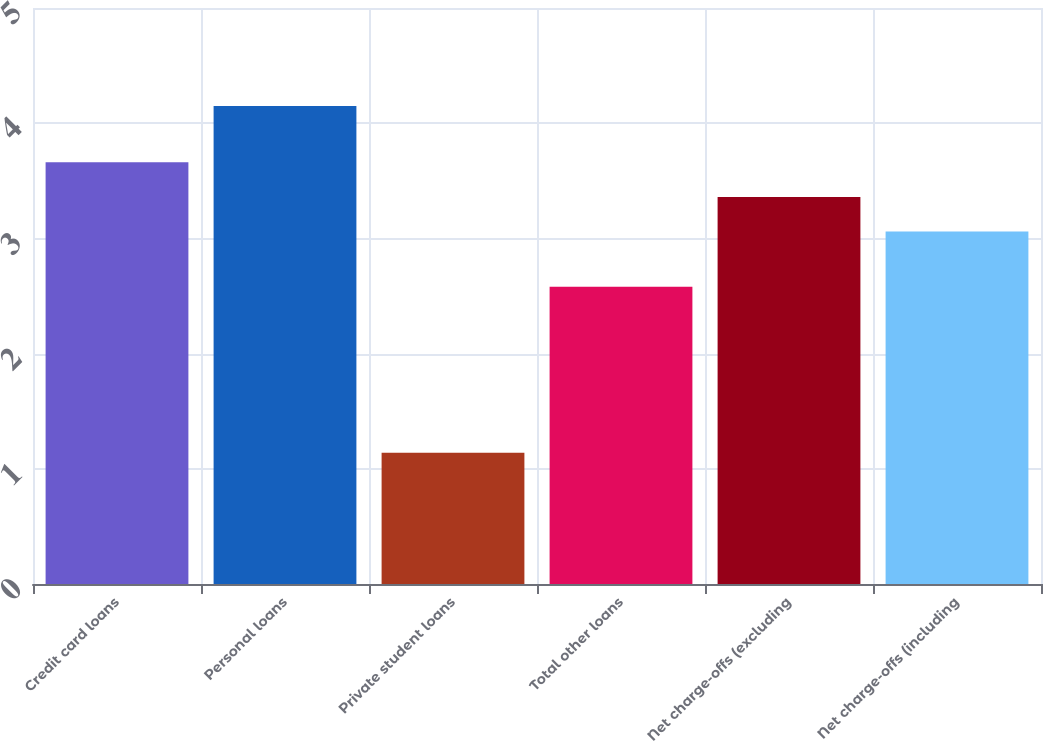Convert chart to OTSL. <chart><loc_0><loc_0><loc_500><loc_500><bar_chart><fcel>Credit card loans<fcel>Personal loans<fcel>Private student loans<fcel>Total other loans<fcel>Net charge-offs (excluding<fcel>Net charge-offs (including<nl><fcel>3.66<fcel>4.15<fcel>1.14<fcel>2.58<fcel>3.36<fcel>3.06<nl></chart> 